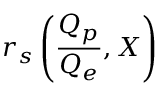Convert formula to latex. <formula><loc_0><loc_0><loc_500><loc_500>r _ { s } \left ( \frac { Q _ { p } } { Q _ { e } } , X \right )</formula> 